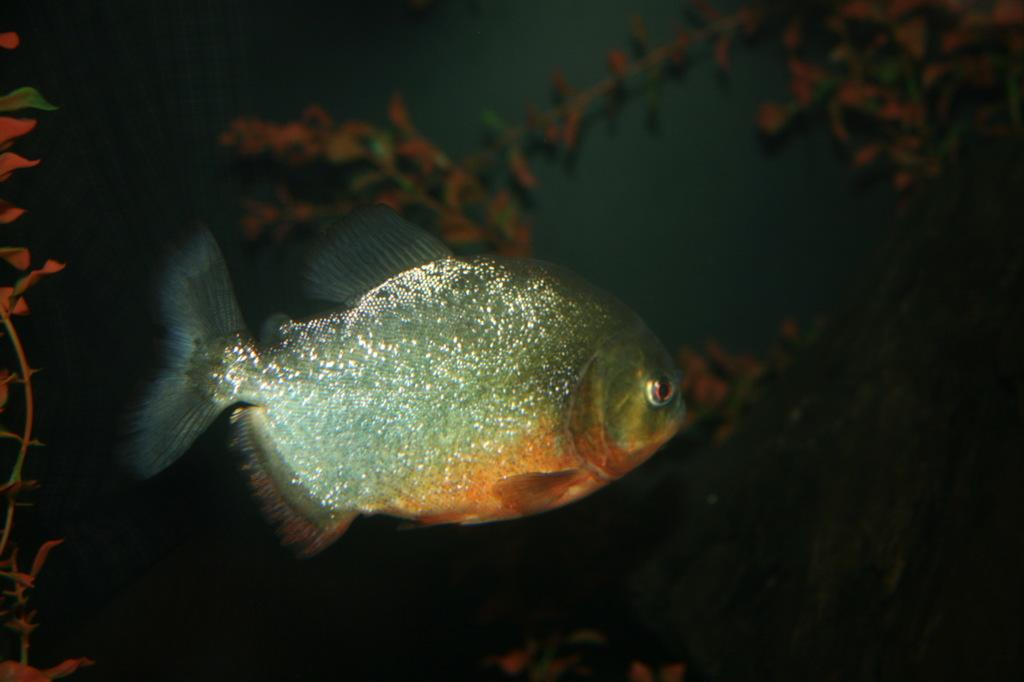What is the main subject of the image? The main subject of the image is an inside view of water. Are there any living creatures visible in the image? Yes, there is a fish in the image. In which direction is the fish facing? The fish is facing towards the right side. What can be seen in the background of the image? There are plants in the background of the image. What type of wine is being served at the committee meeting in the image? There is no committee meeting or wine present in the image; it features an inside view of water with a fish and plants in the background. 